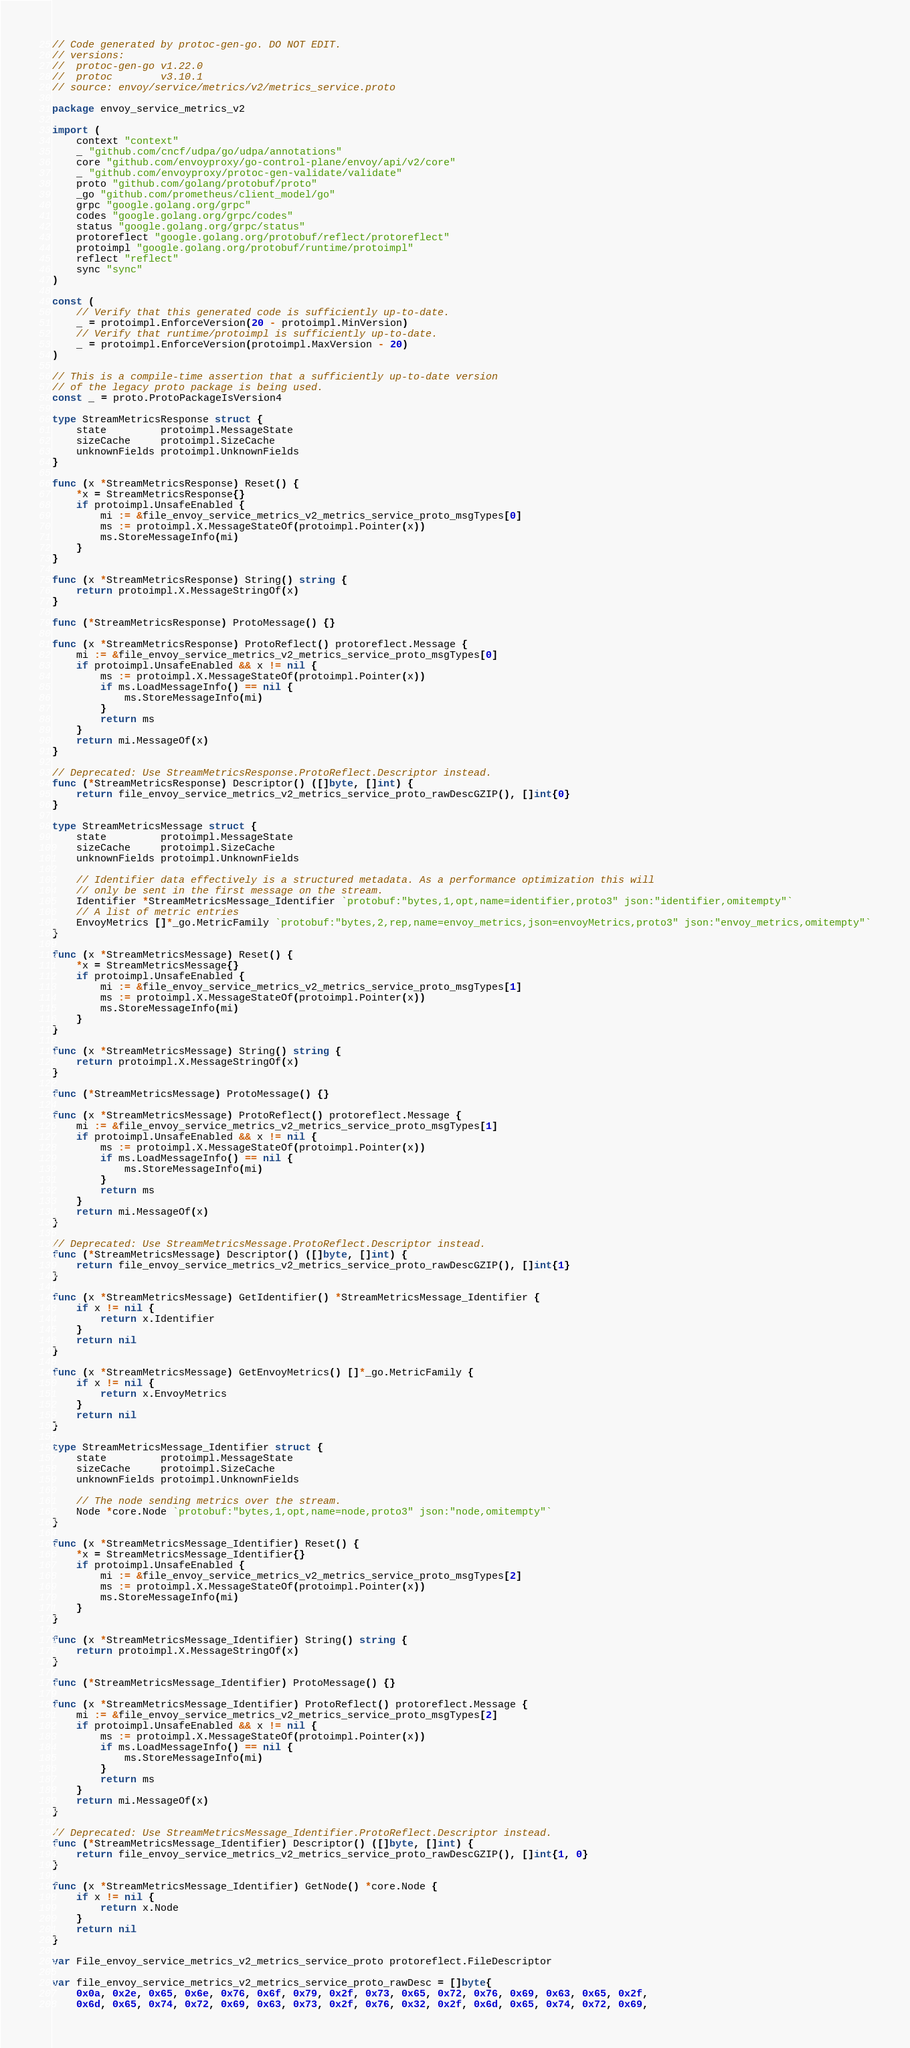<code> <loc_0><loc_0><loc_500><loc_500><_Go_>// Code generated by protoc-gen-go. DO NOT EDIT.
// versions:
// 	protoc-gen-go v1.22.0
// 	protoc        v3.10.1
// source: envoy/service/metrics/v2/metrics_service.proto

package envoy_service_metrics_v2

import (
	context "context"
	_ "github.com/cncf/udpa/go/udpa/annotations"
	core "github.com/envoyproxy/go-control-plane/envoy/api/v2/core"
	_ "github.com/envoyproxy/protoc-gen-validate/validate"
	proto "github.com/golang/protobuf/proto"
	_go "github.com/prometheus/client_model/go"
	grpc "google.golang.org/grpc"
	codes "google.golang.org/grpc/codes"
	status "google.golang.org/grpc/status"
	protoreflect "google.golang.org/protobuf/reflect/protoreflect"
	protoimpl "google.golang.org/protobuf/runtime/protoimpl"
	reflect "reflect"
	sync "sync"
)

const (
	// Verify that this generated code is sufficiently up-to-date.
	_ = protoimpl.EnforceVersion(20 - protoimpl.MinVersion)
	// Verify that runtime/protoimpl is sufficiently up-to-date.
	_ = protoimpl.EnforceVersion(protoimpl.MaxVersion - 20)
)

// This is a compile-time assertion that a sufficiently up-to-date version
// of the legacy proto package is being used.
const _ = proto.ProtoPackageIsVersion4

type StreamMetricsResponse struct {
	state         protoimpl.MessageState
	sizeCache     protoimpl.SizeCache
	unknownFields protoimpl.UnknownFields
}

func (x *StreamMetricsResponse) Reset() {
	*x = StreamMetricsResponse{}
	if protoimpl.UnsafeEnabled {
		mi := &file_envoy_service_metrics_v2_metrics_service_proto_msgTypes[0]
		ms := protoimpl.X.MessageStateOf(protoimpl.Pointer(x))
		ms.StoreMessageInfo(mi)
	}
}

func (x *StreamMetricsResponse) String() string {
	return protoimpl.X.MessageStringOf(x)
}

func (*StreamMetricsResponse) ProtoMessage() {}

func (x *StreamMetricsResponse) ProtoReflect() protoreflect.Message {
	mi := &file_envoy_service_metrics_v2_metrics_service_proto_msgTypes[0]
	if protoimpl.UnsafeEnabled && x != nil {
		ms := protoimpl.X.MessageStateOf(protoimpl.Pointer(x))
		if ms.LoadMessageInfo() == nil {
			ms.StoreMessageInfo(mi)
		}
		return ms
	}
	return mi.MessageOf(x)
}

// Deprecated: Use StreamMetricsResponse.ProtoReflect.Descriptor instead.
func (*StreamMetricsResponse) Descriptor() ([]byte, []int) {
	return file_envoy_service_metrics_v2_metrics_service_proto_rawDescGZIP(), []int{0}
}

type StreamMetricsMessage struct {
	state         protoimpl.MessageState
	sizeCache     protoimpl.SizeCache
	unknownFields protoimpl.UnknownFields

	// Identifier data effectively is a structured metadata. As a performance optimization this will
	// only be sent in the first message on the stream.
	Identifier *StreamMetricsMessage_Identifier `protobuf:"bytes,1,opt,name=identifier,proto3" json:"identifier,omitempty"`
	// A list of metric entries
	EnvoyMetrics []*_go.MetricFamily `protobuf:"bytes,2,rep,name=envoy_metrics,json=envoyMetrics,proto3" json:"envoy_metrics,omitempty"`
}

func (x *StreamMetricsMessage) Reset() {
	*x = StreamMetricsMessage{}
	if protoimpl.UnsafeEnabled {
		mi := &file_envoy_service_metrics_v2_metrics_service_proto_msgTypes[1]
		ms := protoimpl.X.MessageStateOf(protoimpl.Pointer(x))
		ms.StoreMessageInfo(mi)
	}
}

func (x *StreamMetricsMessage) String() string {
	return protoimpl.X.MessageStringOf(x)
}

func (*StreamMetricsMessage) ProtoMessage() {}

func (x *StreamMetricsMessage) ProtoReflect() protoreflect.Message {
	mi := &file_envoy_service_metrics_v2_metrics_service_proto_msgTypes[1]
	if protoimpl.UnsafeEnabled && x != nil {
		ms := protoimpl.X.MessageStateOf(protoimpl.Pointer(x))
		if ms.LoadMessageInfo() == nil {
			ms.StoreMessageInfo(mi)
		}
		return ms
	}
	return mi.MessageOf(x)
}

// Deprecated: Use StreamMetricsMessage.ProtoReflect.Descriptor instead.
func (*StreamMetricsMessage) Descriptor() ([]byte, []int) {
	return file_envoy_service_metrics_v2_metrics_service_proto_rawDescGZIP(), []int{1}
}

func (x *StreamMetricsMessage) GetIdentifier() *StreamMetricsMessage_Identifier {
	if x != nil {
		return x.Identifier
	}
	return nil
}

func (x *StreamMetricsMessage) GetEnvoyMetrics() []*_go.MetricFamily {
	if x != nil {
		return x.EnvoyMetrics
	}
	return nil
}

type StreamMetricsMessage_Identifier struct {
	state         protoimpl.MessageState
	sizeCache     protoimpl.SizeCache
	unknownFields protoimpl.UnknownFields

	// The node sending metrics over the stream.
	Node *core.Node `protobuf:"bytes,1,opt,name=node,proto3" json:"node,omitempty"`
}

func (x *StreamMetricsMessage_Identifier) Reset() {
	*x = StreamMetricsMessage_Identifier{}
	if protoimpl.UnsafeEnabled {
		mi := &file_envoy_service_metrics_v2_metrics_service_proto_msgTypes[2]
		ms := protoimpl.X.MessageStateOf(protoimpl.Pointer(x))
		ms.StoreMessageInfo(mi)
	}
}

func (x *StreamMetricsMessage_Identifier) String() string {
	return protoimpl.X.MessageStringOf(x)
}

func (*StreamMetricsMessage_Identifier) ProtoMessage() {}

func (x *StreamMetricsMessage_Identifier) ProtoReflect() protoreflect.Message {
	mi := &file_envoy_service_metrics_v2_metrics_service_proto_msgTypes[2]
	if protoimpl.UnsafeEnabled && x != nil {
		ms := protoimpl.X.MessageStateOf(protoimpl.Pointer(x))
		if ms.LoadMessageInfo() == nil {
			ms.StoreMessageInfo(mi)
		}
		return ms
	}
	return mi.MessageOf(x)
}

// Deprecated: Use StreamMetricsMessage_Identifier.ProtoReflect.Descriptor instead.
func (*StreamMetricsMessage_Identifier) Descriptor() ([]byte, []int) {
	return file_envoy_service_metrics_v2_metrics_service_proto_rawDescGZIP(), []int{1, 0}
}

func (x *StreamMetricsMessage_Identifier) GetNode() *core.Node {
	if x != nil {
		return x.Node
	}
	return nil
}

var File_envoy_service_metrics_v2_metrics_service_proto protoreflect.FileDescriptor

var file_envoy_service_metrics_v2_metrics_service_proto_rawDesc = []byte{
	0x0a, 0x2e, 0x65, 0x6e, 0x76, 0x6f, 0x79, 0x2f, 0x73, 0x65, 0x72, 0x76, 0x69, 0x63, 0x65, 0x2f,
	0x6d, 0x65, 0x74, 0x72, 0x69, 0x63, 0x73, 0x2f, 0x76, 0x32, 0x2f, 0x6d, 0x65, 0x74, 0x72, 0x69,</code> 